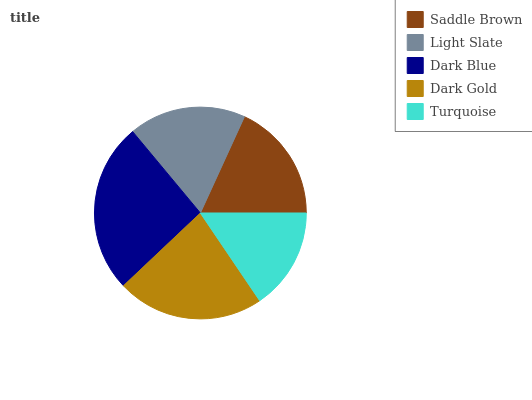Is Turquoise the minimum?
Answer yes or no. Yes. Is Dark Blue the maximum?
Answer yes or no. Yes. Is Light Slate the minimum?
Answer yes or no. No. Is Light Slate the maximum?
Answer yes or no. No. Is Saddle Brown greater than Light Slate?
Answer yes or no. Yes. Is Light Slate less than Saddle Brown?
Answer yes or no. Yes. Is Light Slate greater than Saddle Brown?
Answer yes or no. No. Is Saddle Brown less than Light Slate?
Answer yes or no. No. Is Saddle Brown the high median?
Answer yes or no. Yes. Is Saddle Brown the low median?
Answer yes or no. Yes. Is Dark Gold the high median?
Answer yes or no. No. Is Dark Gold the low median?
Answer yes or no. No. 